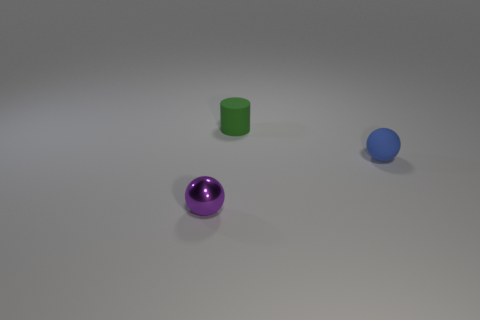What materials do the objects seem to be made of? The sphere in the foreground has a reflective, metallic look, possibly resembling polished stainless steel or chrome, while the green cylinder appears to have a matte surface, suggesting a plastic or painted wood material. The blue sphere has a less reflective surface than the purple sphere, which suggests it could be a matte plastic or rubber material. 